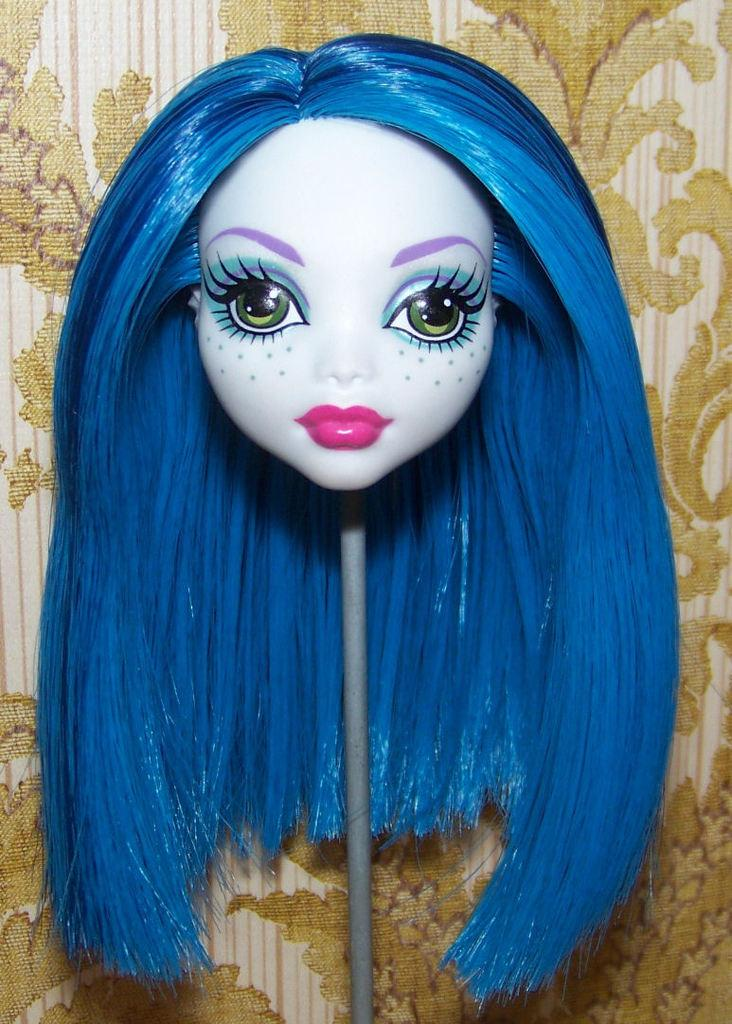What is the main subject of the image? The main subject of the image is a grey object with a doll face. Can you describe the doll face on the grey object? The doll face has blue hair. What can be seen in the background of the image? There are cream-colored designs in the background of the image. How many goats are visible in the image? There are no goats present in the image. What type of muscle is being exercised by the doll face in the image? The image does not depict any muscles or exercise, as it features a grey object with a doll face. 